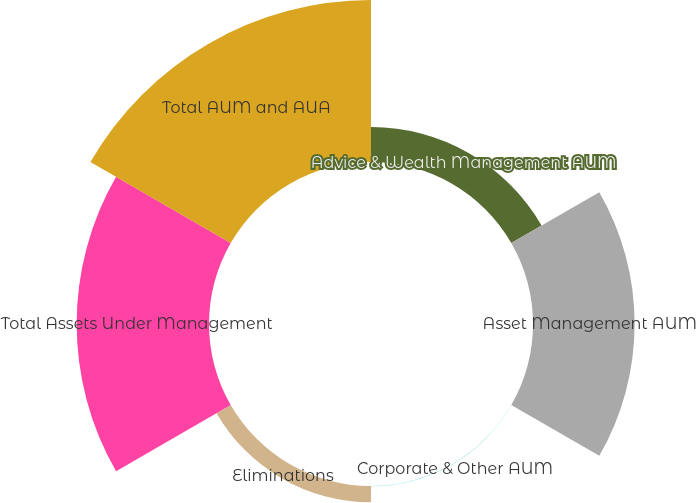Convert chart. <chart><loc_0><loc_0><loc_500><loc_500><pie_chart><fcel>Advice & Wealth Management AUM<fcel>Asset Management AUM<fcel>Corporate & Other AUM<fcel>Eliminations<fcel>Total Assets Under Management<fcel>Total AUM and AUA<nl><fcel>7.82%<fcel>22.71%<fcel>0.04%<fcel>3.65%<fcel>29.58%<fcel>36.21%<nl></chart> 